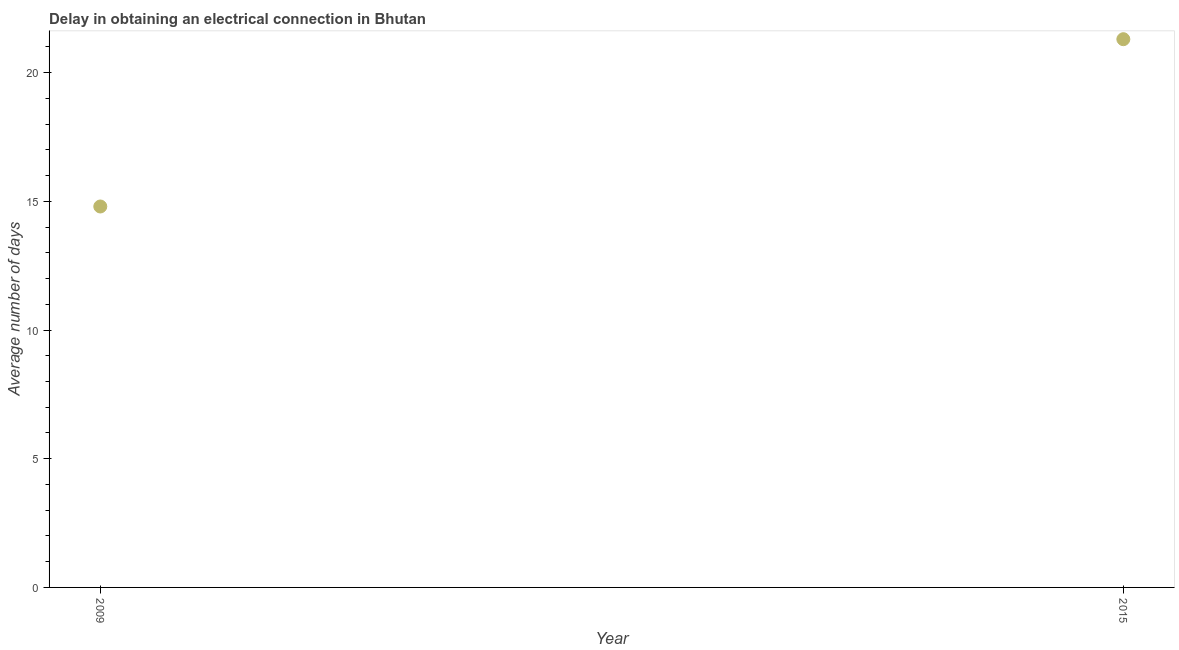What is the dalay in electrical connection in 2009?
Provide a succinct answer. 14.8. Across all years, what is the maximum dalay in electrical connection?
Keep it short and to the point. 21.3. In which year was the dalay in electrical connection maximum?
Offer a very short reply. 2015. What is the sum of the dalay in electrical connection?
Keep it short and to the point. 36.1. What is the average dalay in electrical connection per year?
Your answer should be very brief. 18.05. What is the median dalay in electrical connection?
Give a very brief answer. 18.05. In how many years, is the dalay in electrical connection greater than 1 days?
Offer a terse response. 2. Do a majority of the years between 2009 and 2015 (inclusive) have dalay in electrical connection greater than 5 days?
Your response must be concise. Yes. What is the ratio of the dalay in electrical connection in 2009 to that in 2015?
Keep it short and to the point. 0.69. Is the dalay in electrical connection in 2009 less than that in 2015?
Your response must be concise. Yes. How many dotlines are there?
Provide a short and direct response. 1. How many years are there in the graph?
Provide a short and direct response. 2. Does the graph contain grids?
Your answer should be very brief. No. What is the title of the graph?
Provide a short and direct response. Delay in obtaining an electrical connection in Bhutan. What is the label or title of the X-axis?
Give a very brief answer. Year. What is the label or title of the Y-axis?
Your answer should be compact. Average number of days. What is the Average number of days in 2009?
Ensure brevity in your answer.  14.8. What is the Average number of days in 2015?
Offer a very short reply. 21.3. What is the ratio of the Average number of days in 2009 to that in 2015?
Ensure brevity in your answer.  0.69. 